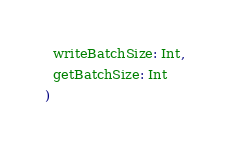Convert code to text. <code><loc_0><loc_0><loc_500><loc_500><_Scala_>  writeBatchSize: Int,
  getBatchSize: Int
)
</code> 